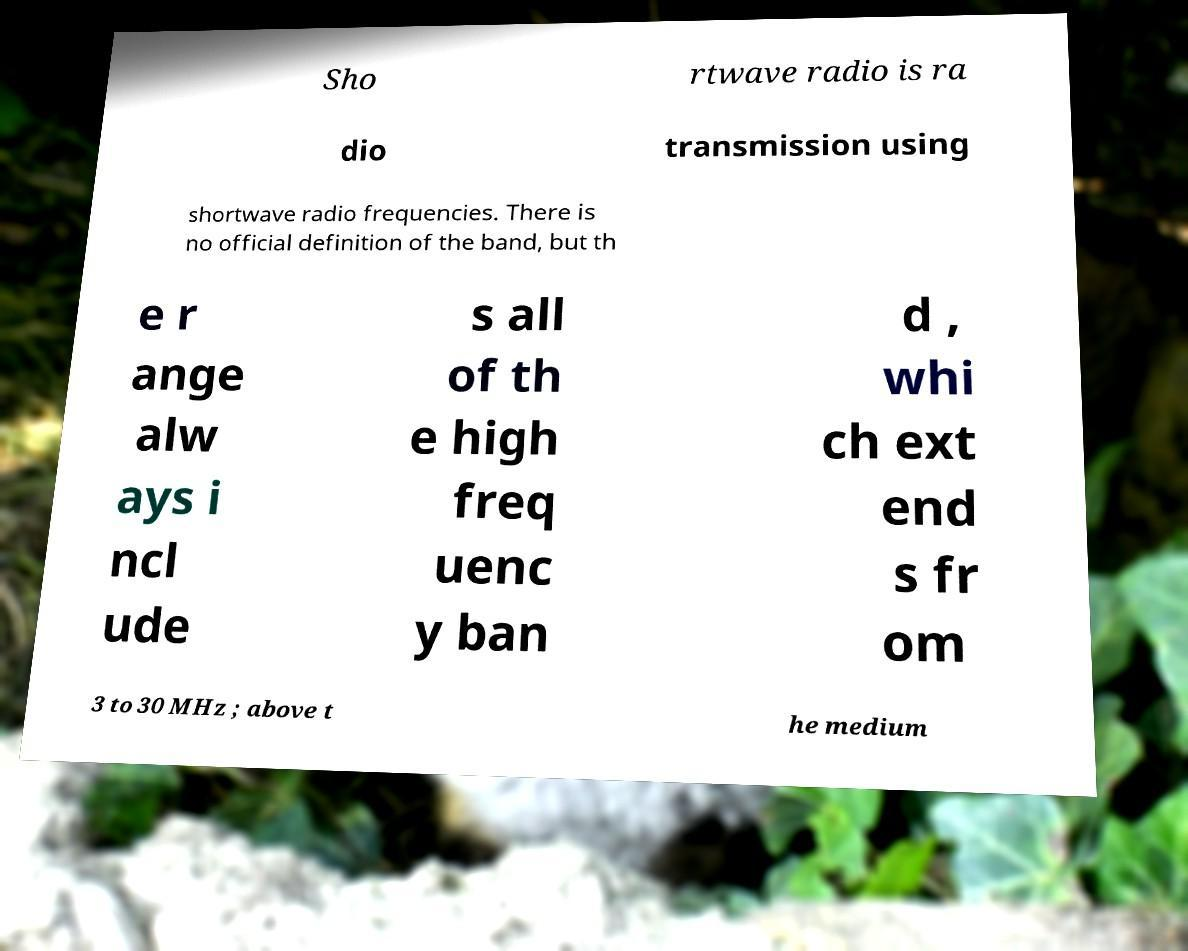Can you accurately transcribe the text from the provided image for me? Sho rtwave radio is ra dio transmission using shortwave radio frequencies. There is no official definition of the band, but th e r ange alw ays i ncl ude s all of th e high freq uenc y ban d , whi ch ext end s fr om 3 to 30 MHz ; above t he medium 